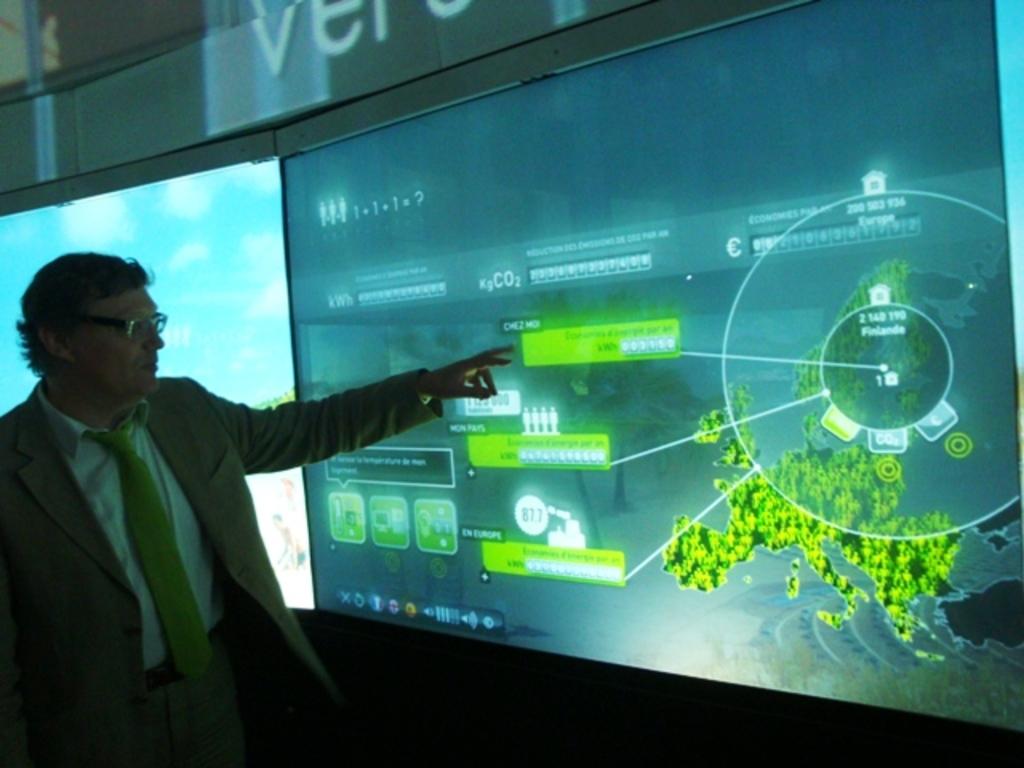What does it say inside of the circle?
Offer a very short reply. Finlande. What number is shown in the white bubble?
Ensure brevity in your answer.  877. 